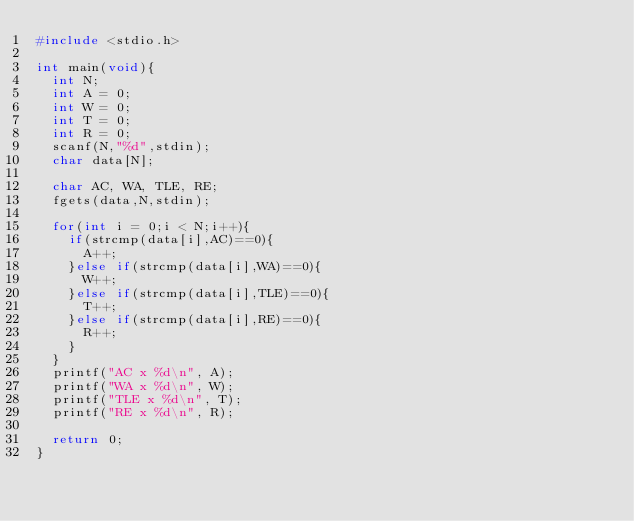Convert code to text. <code><loc_0><loc_0><loc_500><loc_500><_C_>#include <stdio.h>
 
int main(void){
  int N;
  int A = 0;
  int W = 0;
  int T = 0;
  int R = 0;
  scanf(N,"%d",stdin);
  char data[N];
  
  char AC, WA, TLE, RE;
  fgets(data,N,stdin);
 
  for(int i = 0;i < N;i++){
    if(strcmp(data[i],AC)==0){
      A++;
    }else if(strcmp(data[i],WA)==0){
      W++;
    }else if(strcmp(data[i],TLE)==0){
      T++;
    }else if(strcmp(data[i],RE)==0){
      R++;
    }
  }
  printf("AC x %d\n", A);
  printf("WA x %d\n", W);
  printf("TLE x %d\n", T);
  printf("RE x %d\n", R);
  
  return 0;
}</code> 